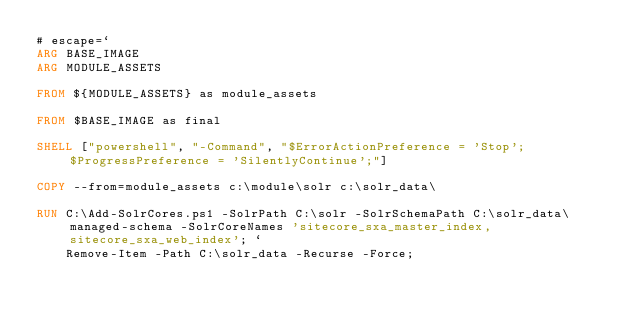<code> <loc_0><loc_0><loc_500><loc_500><_Dockerfile_># escape=`
ARG BASE_IMAGE
ARG MODULE_ASSETS

FROM ${MODULE_ASSETS} as module_assets

FROM $BASE_IMAGE as final

SHELL ["powershell", "-Command", "$ErrorActionPreference = 'Stop'; $ProgressPreference = 'SilentlyContinue';"]

COPY --from=module_assets c:\module\solr c:\solr_data\

RUN C:\Add-SolrCores.ps1 -SolrPath C:\solr -SolrSchemaPath C:\solr_data\managed-schema -SolrCoreNames 'sitecore_sxa_master_index,sitecore_sxa_web_index'; `
    Remove-Item -Path C:\solr_data -Recurse -Force;
</code> 